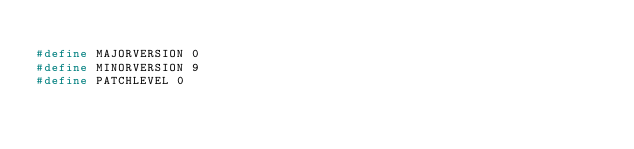Convert code to text. <code><loc_0><loc_0><loc_500><loc_500><_C_>
#define MAJORVERSION 0
#define MINORVERSION 9
#define PATCHLEVEL 0
</code> 